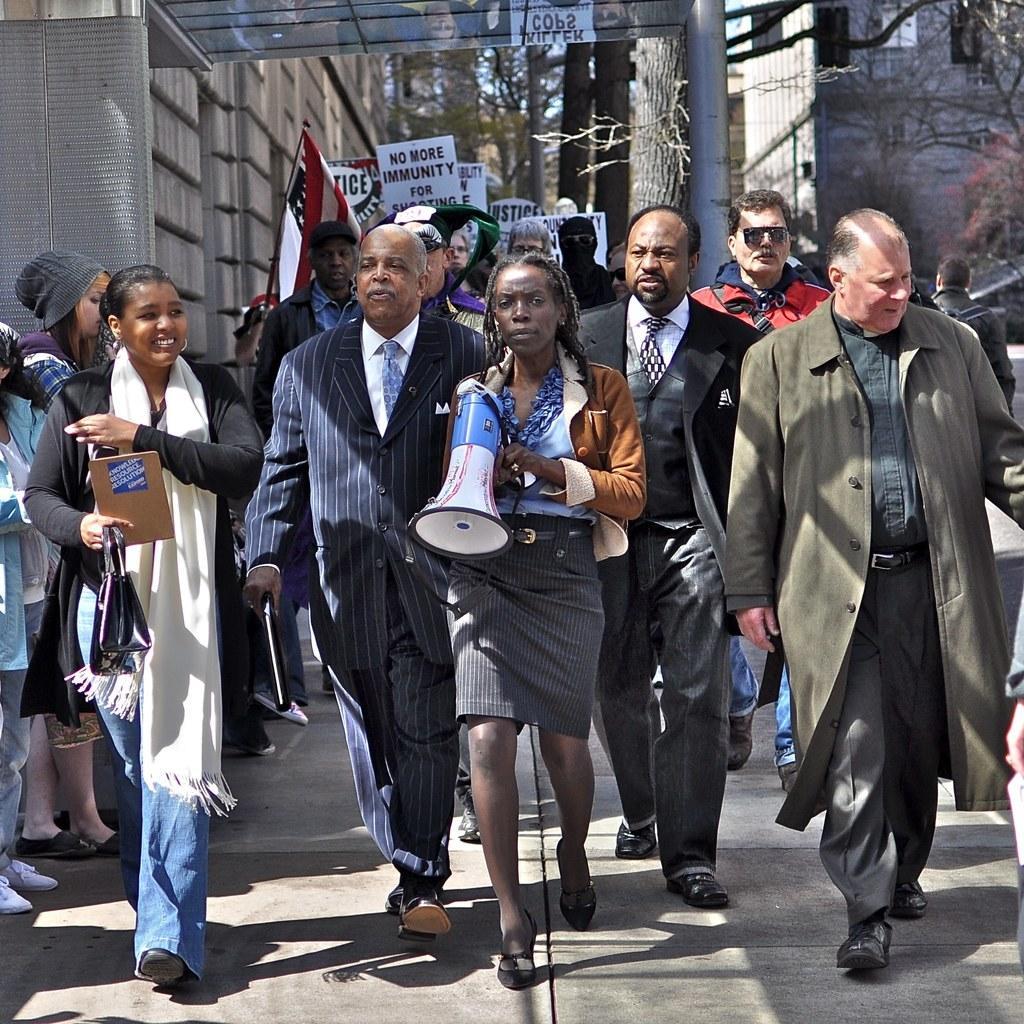Could you give a brief overview of what you see in this image? In this image I can see group of people walking. In front the person is wearing brown jacket and gray color skirt and the person is holding a megaphone. Background I can see few boards and a flag in blue, white and red color and I can also see trees and the sky is in blue color 